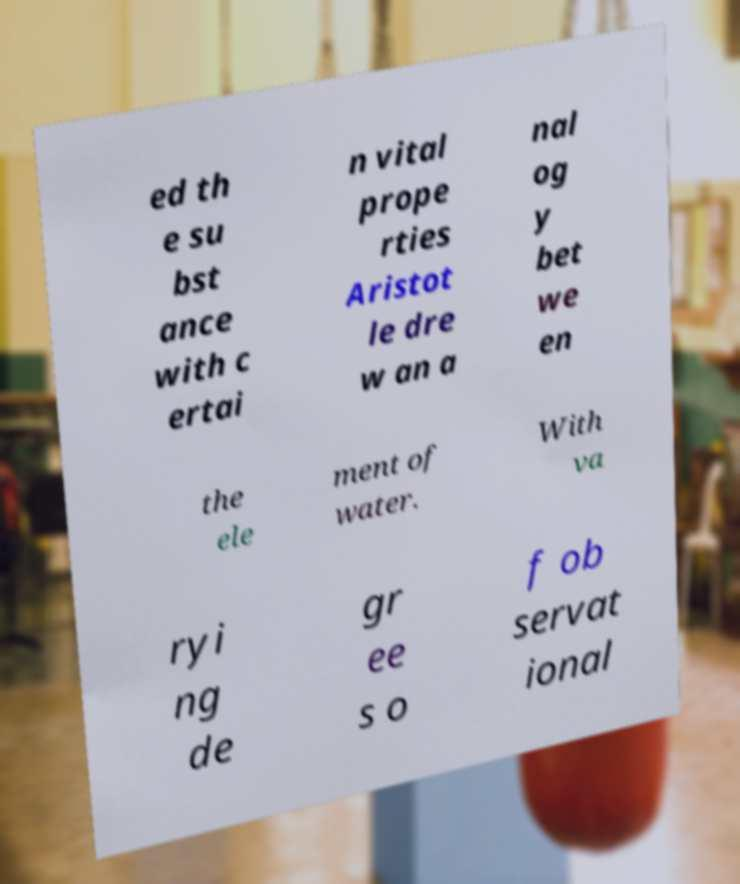Can you accurately transcribe the text from the provided image for me? ed th e su bst ance with c ertai n vital prope rties Aristot le dre w an a nal og y bet we en the ele ment of water. With va ryi ng de gr ee s o f ob servat ional 